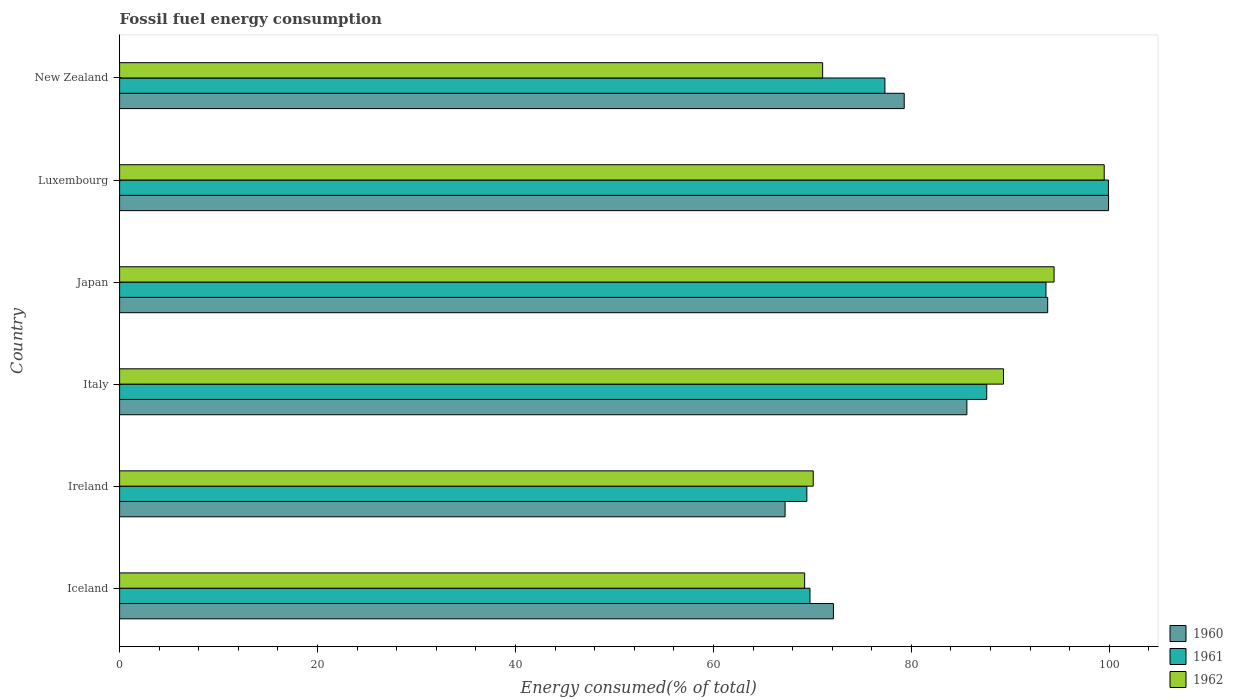How many different coloured bars are there?
Ensure brevity in your answer.  3. How many groups of bars are there?
Offer a terse response. 6. Are the number of bars per tick equal to the number of legend labels?
Your answer should be very brief. Yes. How many bars are there on the 1st tick from the top?
Provide a short and direct response. 3. How many bars are there on the 4th tick from the bottom?
Give a very brief answer. 3. What is the label of the 1st group of bars from the top?
Offer a very short reply. New Zealand. What is the percentage of energy consumed in 1960 in New Zealand?
Keep it short and to the point. 79.28. Across all countries, what is the maximum percentage of energy consumed in 1960?
Your answer should be very brief. 99.92. Across all countries, what is the minimum percentage of energy consumed in 1961?
Offer a terse response. 69.44. In which country was the percentage of energy consumed in 1960 maximum?
Offer a very short reply. Luxembourg. In which country was the percentage of energy consumed in 1961 minimum?
Provide a short and direct response. Ireland. What is the total percentage of energy consumed in 1960 in the graph?
Offer a very short reply. 497.96. What is the difference between the percentage of energy consumed in 1960 in Ireland and that in Japan?
Provide a short and direct response. -26.53. What is the difference between the percentage of energy consumed in 1960 in Japan and the percentage of energy consumed in 1962 in Ireland?
Provide a succinct answer. 23.69. What is the average percentage of energy consumed in 1960 per country?
Your answer should be very brief. 82.99. What is the difference between the percentage of energy consumed in 1961 and percentage of energy consumed in 1960 in Japan?
Keep it short and to the point. -0.17. What is the ratio of the percentage of energy consumed in 1960 in Ireland to that in Japan?
Your answer should be very brief. 0.72. Is the percentage of energy consumed in 1960 in Italy less than that in Luxembourg?
Ensure brevity in your answer.  Yes. Is the difference between the percentage of energy consumed in 1961 in Iceland and Italy greater than the difference between the percentage of energy consumed in 1960 in Iceland and Italy?
Keep it short and to the point. No. What is the difference between the highest and the second highest percentage of energy consumed in 1961?
Offer a terse response. 6.31. What is the difference between the highest and the lowest percentage of energy consumed in 1960?
Your response must be concise. 32.68. In how many countries, is the percentage of energy consumed in 1962 greater than the average percentage of energy consumed in 1962 taken over all countries?
Your answer should be very brief. 3. Is the sum of the percentage of energy consumed in 1961 in Ireland and Luxembourg greater than the maximum percentage of energy consumed in 1962 across all countries?
Your response must be concise. Yes. What does the 3rd bar from the top in Japan represents?
Ensure brevity in your answer.  1960. What does the 1st bar from the bottom in Japan represents?
Your answer should be compact. 1960. Are all the bars in the graph horizontal?
Keep it short and to the point. Yes. Are the values on the major ticks of X-axis written in scientific E-notation?
Provide a succinct answer. No. Does the graph contain any zero values?
Give a very brief answer. No. Does the graph contain grids?
Your response must be concise. No. How many legend labels are there?
Ensure brevity in your answer.  3. What is the title of the graph?
Make the answer very short. Fossil fuel energy consumption. What is the label or title of the X-axis?
Provide a short and direct response. Energy consumed(% of total). What is the Energy consumed(% of total) in 1960 in Iceland?
Your answer should be compact. 72.13. What is the Energy consumed(% of total) in 1961 in Iceland?
Give a very brief answer. 69.76. What is the Energy consumed(% of total) of 1962 in Iceland?
Offer a terse response. 69.22. What is the Energy consumed(% of total) of 1960 in Ireland?
Your answer should be compact. 67.24. What is the Energy consumed(% of total) in 1961 in Ireland?
Your response must be concise. 69.44. What is the Energy consumed(% of total) of 1962 in Ireland?
Your answer should be very brief. 70.09. What is the Energy consumed(% of total) of 1960 in Italy?
Your answer should be very brief. 85.61. What is the Energy consumed(% of total) of 1961 in Italy?
Provide a succinct answer. 87.62. What is the Energy consumed(% of total) in 1962 in Italy?
Ensure brevity in your answer.  89.31. What is the Energy consumed(% of total) of 1960 in Japan?
Keep it short and to the point. 93.78. What is the Energy consumed(% of total) of 1961 in Japan?
Provide a succinct answer. 93.6. What is the Energy consumed(% of total) of 1962 in Japan?
Your answer should be compact. 94.42. What is the Energy consumed(% of total) of 1960 in Luxembourg?
Your answer should be very brief. 99.92. What is the Energy consumed(% of total) in 1961 in Luxembourg?
Your response must be concise. 99.91. What is the Energy consumed(% of total) in 1962 in Luxembourg?
Provide a succinct answer. 99.49. What is the Energy consumed(% of total) of 1960 in New Zealand?
Keep it short and to the point. 79.28. What is the Energy consumed(% of total) of 1961 in New Zealand?
Your answer should be compact. 77.33. What is the Energy consumed(% of total) in 1962 in New Zealand?
Your answer should be very brief. 71.04. Across all countries, what is the maximum Energy consumed(% of total) in 1960?
Your response must be concise. 99.92. Across all countries, what is the maximum Energy consumed(% of total) of 1961?
Keep it short and to the point. 99.91. Across all countries, what is the maximum Energy consumed(% of total) of 1962?
Offer a very short reply. 99.49. Across all countries, what is the minimum Energy consumed(% of total) in 1960?
Your answer should be very brief. 67.24. Across all countries, what is the minimum Energy consumed(% of total) of 1961?
Offer a very short reply. 69.44. Across all countries, what is the minimum Energy consumed(% of total) in 1962?
Provide a succinct answer. 69.22. What is the total Energy consumed(% of total) of 1960 in the graph?
Your answer should be very brief. 497.96. What is the total Energy consumed(% of total) of 1961 in the graph?
Your answer should be compact. 497.66. What is the total Energy consumed(% of total) of 1962 in the graph?
Offer a terse response. 493.56. What is the difference between the Energy consumed(% of total) of 1960 in Iceland and that in Ireland?
Offer a terse response. 4.89. What is the difference between the Energy consumed(% of total) of 1961 in Iceland and that in Ireland?
Offer a very short reply. 0.32. What is the difference between the Energy consumed(% of total) in 1962 in Iceland and that in Ireland?
Keep it short and to the point. -0.87. What is the difference between the Energy consumed(% of total) in 1960 in Iceland and that in Italy?
Offer a terse response. -13.48. What is the difference between the Energy consumed(% of total) of 1961 in Iceland and that in Italy?
Offer a very short reply. -17.86. What is the difference between the Energy consumed(% of total) of 1962 in Iceland and that in Italy?
Give a very brief answer. -20.09. What is the difference between the Energy consumed(% of total) of 1960 in Iceland and that in Japan?
Your answer should be compact. -21.65. What is the difference between the Energy consumed(% of total) in 1961 in Iceland and that in Japan?
Your answer should be very brief. -23.85. What is the difference between the Energy consumed(% of total) in 1962 in Iceland and that in Japan?
Provide a short and direct response. -25.2. What is the difference between the Energy consumed(% of total) in 1960 in Iceland and that in Luxembourg?
Your answer should be very brief. -27.8. What is the difference between the Energy consumed(% of total) in 1961 in Iceland and that in Luxembourg?
Your response must be concise. -30.16. What is the difference between the Energy consumed(% of total) in 1962 in Iceland and that in Luxembourg?
Ensure brevity in your answer.  -30.27. What is the difference between the Energy consumed(% of total) in 1960 in Iceland and that in New Zealand?
Give a very brief answer. -7.15. What is the difference between the Energy consumed(% of total) in 1961 in Iceland and that in New Zealand?
Offer a very short reply. -7.57. What is the difference between the Energy consumed(% of total) of 1962 in Iceland and that in New Zealand?
Give a very brief answer. -1.82. What is the difference between the Energy consumed(% of total) of 1960 in Ireland and that in Italy?
Your answer should be compact. -18.37. What is the difference between the Energy consumed(% of total) of 1961 in Ireland and that in Italy?
Offer a terse response. -18.18. What is the difference between the Energy consumed(% of total) in 1962 in Ireland and that in Italy?
Your answer should be very brief. -19.23. What is the difference between the Energy consumed(% of total) in 1960 in Ireland and that in Japan?
Ensure brevity in your answer.  -26.53. What is the difference between the Energy consumed(% of total) of 1961 in Ireland and that in Japan?
Ensure brevity in your answer.  -24.16. What is the difference between the Energy consumed(% of total) in 1962 in Ireland and that in Japan?
Ensure brevity in your answer.  -24.34. What is the difference between the Energy consumed(% of total) in 1960 in Ireland and that in Luxembourg?
Your response must be concise. -32.68. What is the difference between the Energy consumed(% of total) in 1961 in Ireland and that in Luxembourg?
Provide a succinct answer. -30.47. What is the difference between the Energy consumed(% of total) in 1962 in Ireland and that in Luxembourg?
Provide a succinct answer. -29.4. What is the difference between the Energy consumed(% of total) in 1960 in Ireland and that in New Zealand?
Offer a terse response. -12.04. What is the difference between the Energy consumed(% of total) of 1961 in Ireland and that in New Zealand?
Provide a succinct answer. -7.89. What is the difference between the Energy consumed(% of total) of 1962 in Ireland and that in New Zealand?
Ensure brevity in your answer.  -0.95. What is the difference between the Energy consumed(% of total) in 1960 in Italy and that in Japan?
Your response must be concise. -8.17. What is the difference between the Energy consumed(% of total) of 1961 in Italy and that in Japan?
Your answer should be very brief. -5.99. What is the difference between the Energy consumed(% of total) of 1962 in Italy and that in Japan?
Make the answer very short. -5.11. What is the difference between the Energy consumed(% of total) of 1960 in Italy and that in Luxembourg?
Your answer should be compact. -14.31. What is the difference between the Energy consumed(% of total) in 1961 in Italy and that in Luxembourg?
Offer a very short reply. -12.3. What is the difference between the Energy consumed(% of total) in 1962 in Italy and that in Luxembourg?
Offer a very short reply. -10.18. What is the difference between the Energy consumed(% of total) in 1960 in Italy and that in New Zealand?
Make the answer very short. 6.33. What is the difference between the Energy consumed(% of total) of 1961 in Italy and that in New Zealand?
Your response must be concise. 10.29. What is the difference between the Energy consumed(% of total) in 1962 in Italy and that in New Zealand?
Your answer should be compact. 18.27. What is the difference between the Energy consumed(% of total) in 1960 in Japan and that in Luxembourg?
Offer a terse response. -6.15. What is the difference between the Energy consumed(% of total) in 1961 in Japan and that in Luxembourg?
Provide a short and direct response. -6.31. What is the difference between the Energy consumed(% of total) of 1962 in Japan and that in Luxembourg?
Your answer should be very brief. -5.07. What is the difference between the Energy consumed(% of total) in 1960 in Japan and that in New Zealand?
Give a very brief answer. 14.5. What is the difference between the Energy consumed(% of total) of 1961 in Japan and that in New Zealand?
Your answer should be very brief. 16.28. What is the difference between the Energy consumed(% of total) in 1962 in Japan and that in New Zealand?
Give a very brief answer. 23.38. What is the difference between the Energy consumed(% of total) of 1960 in Luxembourg and that in New Zealand?
Your answer should be compact. 20.65. What is the difference between the Energy consumed(% of total) in 1961 in Luxembourg and that in New Zealand?
Your answer should be compact. 22.58. What is the difference between the Energy consumed(% of total) of 1962 in Luxembourg and that in New Zealand?
Give a very brief answer. 28.45. What is the difference between the Energy consumed(% of total) of 1960 in Iceland and the Energy consumed(% of total) of 1961 in Ireland?
Keep it short and to the point. 2.69. What is the difference between the Energy consumed(% of total) in 1960 in Iceland and the Energy consumed(% of total) in 1962 in Ireland?
Provide a succinct answer. 2.04. What is the difference between the Energy consumed(% of total) of 1961 in Iceland and the Energy consumed(% of total) of 1962 in Ireland?
Provide a short and direct response. -0.33. What is the difference between the Energy consumed(% of total) of 1960 in Iceland and the Energy consumed(% of total) of 1961 in Italy?
Make the answer very short. -15.49. What is the difference between the Energy consumed(% of total) of 1960 in Iceland and the Energy consumed(% of total) of 1962 in Italy?
Provide a short and direct response. -17.18. What is the difference between the Energy consumed(% of total) in 1961 in Iceland and the Energy consumed(% of total) in 1962 in Italy?
Your answer should be compact. -19.55. What is the difference between the Energy consumed(% of total) in 1960 in Iceland and the Energy consumed(% of total) in 1961 in Japan?
Provide a succinct answer. -21.48. What is the difference between the Energy consumed(% of total) in 1960 in Iceland and the Energy consumed(% of total) in 1962 in Japan?
Make the answer very short. -22.29. What is the difference between the Energy consumed(% of total) in 1961 in Iceland and the Energy consumed(% of total) in 1962 in Japan?
Your answer should be very brief. -24.66. What is the difference between the Energy consumed(% of total) of 1960 in Iceland and the Energy consumed(% of total) of 1961 in Luxembourg?
Your answer should be very brief. -27.78. What is the difference between the Energy consumed(% of total) in 1960 in Iceland and the Energy consumed(% of total) in 1962 in Luxembourg?
Provide a short and direct response. -27.36. What is the difference between the Energy consumed(% of total) in 1961 in Iceland and the Energy consumed(% of total) in 1962 in Luxembourg?
Your response must be concise. -29.73. What is the difference between the Energy consumed(% of total) in 1960 in Iceland and the Energy consumed(% of total) in 1961 in New Zealand?
Make the answer very short. -5.2. What is the difference between the Energy consumed(% of total) in 1960 in Iceland and the Energy consumed(% of total) in 1962 in New Zealand?
Provide a succinct answer. 1.09. What is the difference between the Energy consumed(% of total) in 1961 in Iceland and the Energy consumed(% of total) in 1962 in New Zealand?
Provide a succinct answer. -1.28. What is the difference between the Energy consumed(% of total) in 1960 in Ireland and the Energy consumed(% of total) in 1961 in Italy?
Your answer should be very brief. -20.38. What is the difference between the Energy consumed(% of total) of 1960 in Ireland and the Energy consumed(% of total) of 1962 in Italy?
Offer a very short reply. -22.07. What is the difference between the Energy consumed(% of total) in 1961 in Ireland and the Energy consumed(% of total) in 1962 in Italy?
Ensure brevity in your answer.  -19.87. What is the difference between the Energy consumed(% of total) in 1960 in Ireland and the Energy consumed(% of total) in 1961 in Japan?
Ensure brevity in your answer.  -26.36. What is the difference between the Energy consumed(% of total) of 1960 in Ireland and the Energy consumed(% of total) of 1962 in Japan?
Offer a terse response. -27.18. What is the difference between the Energy consumed(% of total) in 1961 in Ireland and the Energy consumed(% of total) in 1962 in Japan?
Give a very brief answer. -24.98. What is the difference between the Energy consumed(% of total) of 1960 in Ireland and the Energy consumed(% of total) of 1961 in Luxembourg?
Keep it short and to the point. -32.67. What is the difference between the Energy consumed(% of total) of 1960 in Ireland and the Energy consumed(% of total) of 1962 in Luxembourg?
Make the answer very short. -32.25. What is the difference between the Energy consumed(% of total) in 1961 in Ireland and the Energy consumed(% of total) in 1962 in Luxembourg?
Ensure brevity in your answer.  -30.05. What is the difference between the Energy consumed(% of total) in 1960 in Ireland and the Energy consumed(% of total) in 1961 in New Zealand?
Provide a succinct answer. -10.09. What is the difference between the Energy consumed(% of total) in 1960 in Ireland and the Energy consumed(% of total) in 1962 in New Zealand?
Provide a succinct answer. -3.79. What is the difference between the Energy consumed(% of total) of 1961 in Ireland and the Energy consumed(% of total) of 1962 in New Zealand?
Offer a very short reply. -1.6. What is the difference between the Energy consumed(% of total) in 1960 in Italy and the Energy consumed(% of total) in 1961 in Japan?
Your response must be concise. -7.99. What is the difference between the Energy consumed(% of total) of 1960 in Italy and the Energy consumed(% of total) of 1962 in Japan?
Ensure brevity in your answer.  -8.81. What is the difference between the Energy consumed(% of total) of 1961 in Italy and the Energy consumed(% of total) of 1962 in Japan?
Offer a terse response. -6.8. What is the difference between the Energy consumed(% of total) in 1960 in Italy and the Energy consumed(% of total) in 1961 in Luxembourg?
Give a very brief answer. -14.3. What is the difference between the Energy consumed(% of total) of 1960 in Italy and the Energy consumed(% of total) of 1962 in Luxembourg?
Make the answer very short. -13.88. What is the difference between the Energy consumed(% of total) of 1961 in Italy and the Energy consumed(% of total) of 1962 in Luxembourg?
Your response must be concise. -11.87. What is the difference between the Energy consumed(% of total) of 1960 in Italy and the Energy consumed(% of total) of 1961 in New Zealand?
Your answer should be very brief. 8.28. What is the difference between the Energy consumed(% of total) in 1960 in Italy and the Energy consumed(% of total) in 1962 in New Zealand?
Your response must be concise. 14.57. What is the difference between the Energy consumed(% of total) in 1961 in Italy and the Energy consumed(% of total) in 1962 in New Zealand?
Keep it short and to the point. 16.58. What is the difference between the Energy consumed(% of total) of 1960 in Japan and the Energy consumed(% of total) of 1961 in Luxembourg?
Provide a short and direct response. -6.14. What is the difference between the Energy consumed(% of total) in 1960 in Japan and the Energy consumed(% of total) in 1962 in Luxembourg?
Your answer should be very brief. -5.71. What is the difference between the Energy consumed(% of total) of 1961 in Japan and the Energy consumed(% of total) of 1962 in Luxembourg?
Ensure brevity in your answer.  -5.88. What is the difference between the Energy consumed(% of total) of 1960 in Japan and the Energy consumed(% of total) of 1961 in New Zealand?
Keep it short and to the point. 16.45. What is the difference between the Energy consumed(% of total) of 1960 in Japan and the Energy consumed(% of total) of 1962 in New Zealand?
Provide a short and direct response. 22.74. What is the difference between the Energy consumed(% of total) of 1961 in Japan and the Energy consumed(% of total) of 1962 in New Zealand?
Make the answer very short. 22.57. What is the difference between the Energy consumed(% of total) in 1960 in Luxembourg and the Energy consumed(% of total) in 1961 in New Zealand?
Your response must be concise. 22.6. What is the difference between the Energy consumed(% of total) in 1960 in Luxembourg and the Energy consumed(% of total) in 1962 in New Zealand?
Offer a very short reply. 28.89. What is the difference between the Energy consumed(% of total) of 1961 in Luxembourg and the Energy consumed(% of total) of 1962 in New Zealand?
Make the answer very short. 28.88. What is the average Energy consumed(% of total) in 1960 per country?
Offer a terse response. 82.99. What is the average Energy consumed(% of total) of 1961 per country?
Ensure brevity in your answer.  82.94. What is the average Energy consumed(% of total) in 1962 per country?
Offer a very short reply. 82.26. What is the difference between the Energy consumed(% of total) in 1960 and Energy consumed(% of total) in 1961 in Iceland?
Your answer should be very brief. 2.37. What is the difference between the Energy consumed(% of total) in 1960 and Energy consumed(% of total) in 1962 in Iceland?
Make the answer very short. 2.91. What is the difference between the Energy consumed(% of total) in 1961 and Energy consumed(% of total) in 1962 in Iceland?
Ensure brevity in your answer.  0.54. What is the difference between the Energy consumed(% of total) in 1960 and Energy consumed(% of total) in 1961 in Ireland?
Provide a short and direct response. -2.2. What is the difference between the Energy consumed(% of total) of 1960 and Energy consumed(% of total) of 1962 in Ireland?
Your response must be concise. -2.84. What is the difference between the Energy consumed(% of total) of 1961 and Energy consumed(% of total) of 1962 in Ireland?
Make the answer very short. -0.65. What is the difference between the Energy consumed(% of total) of 1960 and Energy consumed(% of total) of 1961 in Italy?
Your response must be concise. -2.01. What is the difference between the Energy consumed(% of total) of 1960 and Energy consumed(% of total) of 1962 in Italy?
Ensure brevity in your answer.  -3.7. What is the difference between the Energy consumed(% of total) of 1961 and Energy consumed(% of total) of 1962 in Italy?
Your answer should be very brief. -1.69. What is the difference between the Energy consumed(% of total) of 1960 and Energy consumed(% of total) of 1961 in Japan?
Offer a very short reply. 0.17. What is the difference between the Energy consumed(% of total) in 1960 and Energy consumed(% of total) in 1962 in Japan?
Ensure brevity in your answer.  -0.64. What is the difference between the Energy consumed(% of total) of 1961 and Energy consumed(% of total) of 1962 in Japan?
Keep it short and to the point. -0.82. What is the difference between the Energy consumed(% of total) of 1960 and Energy consumed(% of total) of 1961 in Luxembourg?
Provide a short and direct response. 0.01. What is the difference between the Energy consumed(% of total) in 1960 and Energy consumed(% of total) in 1962 in Luxembourg?
Make the answer very short. 0.44. What is the difference between the Energy consumed(% of total) in 1961 and Energy consumed(% of total) in 1962 in Luxembourg?
Offer a very short reply. 0.42. What is the difference between the Energy consumed(% of total) in 1960 and Energy consumed(% of total) in 1961 in New Zealand?
Keep it short and to the point. 1.95. What is the difference between the Energy consumed(% of total) in 1960 and Energy consumed(% of total) in 1962 in New Zealand?
Ensure brevity in your answer.  8.24. What is the difference between the Energy consumed(% of total) of 1961 and Energy consumed(% of total) of 1962 in New Zealand?
Your answer should be compact. 6.29. What is the ratio of the Energy consumed(% of total) in 1960 in Iceland to that in Ireland?
Offer a very short reply. 1.07. What is the ratio of the Energy consumed(% of total) in 1961 in Iceland to that in Ireland?
Keep it short and to the point. 1. What is the ratio of the Energy consumed(% of total) in 1962 in Iceland to that in Ireland?
Your answer should be very brief. 0.99. What is the ratio of the Energy consumed(% of total) of 1960 in Iceland to that in Italy?
Make the answer very short. 0.84. What is the ratio of the Energy consumed(% of total) in 1961 in Iceland to that in Italy?
Provide a short and direct response. 0.8. What is the ratio of the Energy consumed(% of total) of 1962 in Iceland to that in Italy?
Your answer should be very brief. 0.78. What is the ratio of the Energy consumed(% of total) of 1960 in Iceland to that in Japan?
Offer a very short reply. 0.77. What is the ratio of the Energy consumed(% of total) in 1961 in Iceland to that in Japan?
Ensure brevity in your answer.  0.75. What is the ratio of the Energy consumed(% of total) in 1962 in Iceland to that in Japan?
Your response must be concise. 0.73. What is the ratio of the Energy consumed(% of total) in 1960 in Iceland to that in Luxembourg?
Make the answer very short. 0.72. What is the ratio of the Energy consumed(% of total) in 1961 in Iceland to that in Luxembourg?
Keep it short and to the point. 0.7. What is the ratio of the Energy consumed(% of total) of 1962 in Iceland to that in Luxembourg?
Your response must be concise. 0.7. What is the ratio of the Energy consumed(% of total) of 1960 in Iceland to that in New Zealand?
Keep it short and to the point. 0.91. What is the ratio of the Energy consumed(% of total) in 1961 in Iceland to that in New Zealand?
Make the answer very short. 0.9. What is the ratio of the Energy consumed(% of total) in 1962 in Iceland to that in New Zealand?
Make the answer very short. 0.97. What is the ratio of the Energy consumed(% of total) in 1960 in Ireland to that in Italy?
Your answer should be very brief. 0.79. What is the ratio of the Energy consumed(% of total) of 1961 in Ireland to that in Italy?
Make the answer very short. 0.79. What is the ratio of the Energy consumed(% of total) of 1962 in Ireland to that in Italy?
Provide a succinct answer. 0.78. What is the ratio of the Energy consumed(% of total) in 1960 in Ireland to that in Japan?
Make the answer very short. 0.72. What is the ratio of the Energy consumed(% of total) in 1961 in Ireland to that in Japan?
Keep it short and to the point. 0.74. What is the ratio of the Energy consumed(% of total) in 1962 in Ireland to that in Japan?
Ensure brevity in your answer.  0.74. What is the ratio of the Energy consumed(% of total) in 1960 in Ireland to that in Luxembourg?
Provide a short and direct response. 0.67. What is the ratio of the Energy consumed(% of total) of 1961 in Ireland to that in Luxembourg?
Provide a succinct answer. 0.69. What is the ratio of the Energy consumed(% of total) of 1962 in Ireland to that in Luxembourg?
Give a very brief answer. 0.7. What is the ratio of the Energy consumed(% of total) of 1960 in Ireland to that in New Zealand?
Ensure brevity in your answer.  0.85. What is the ratio of the Energy consumed(% of total) in 1961 in Ireland to that in New Zealand?
Offer a terse response. 0.9. What is the ratio of the Energy consumed(% of total) in 1962 in Ireland to that in New Zealand?
Your answer should be very brief. 0.99. What is the ratio of the Energy consumed(% of total) of 1960 in Italy to that in Japan?
Ensure brevity in your answer.  0.91. What is the ratio of the Energy consumed(% of total) in 1961 in Italy to that in Japan?
Give a very brief answer. 0.94. What is the ratio of the Energy consumed(% of total) of 1962 in Italy to that in Japan?
Your answer should be very brief. 0.95. What is the ratio of the Energy consumed(% of total) of 1960 in Italy to that in Luxembourg?
Your response must be concise. 0.86. What is the ratio of the Energy consumed(% of total) in 1961 in Italy to that in Luxembourg?
Your answer should be compact. 0.88. What is the ratio of the Energy consumed(% of total) of 1962 in Italy to that in Luxembourg?
Provide a short and direct response. 0.9. What is the ratio of the Energy consumed(% of total) in 1960 in Italy to that in New Zealand?
Provide a short and direct response. 1.08. What is the ratio of the Energy consumed(% of total) in 1961 in Italy to that in New Zealand?
Make the answer very short. 1.13. What is the ratio of the Energy consumed(% of total) of 1962 in Italy to that in New Zealand?
Your answer should be compact. 1.26. What is the ratio of the Energy consumed(% of total) in 1960 in Japan to that in Luxembourg?
Ensure brevity in your answer.  0.94. What is the ratio of the Energy consumed(% of total) in 1961 in Japan to that in Luxembourg?
Your answer should be very brief. 0.94. What is the ratio of the Energy consumed(% of total) of 1962 in Japan to that in Luxembourg?
Keep it short and to the point. 0.95. What is the ratio of the Energy consumed(% of total) in 1960 in Japan to that in New Zealand?
Give a very brief answer. 1.18. What is the ratio of the Energy consumed(% of total) of 1961 in Japan to that in New Zealand?
Give a very brief answer. 1.21. What is the ratio of the Energy consumed(% of total) of 1962 in Japan to that in New Zealand?
Give a very brief answer. 1.33. What is the ratio of the Energy consumed(% of total) in 1960 in Luxembourg to that in New Zealand?
Give a very brief answer. 1.26. What is the ratio of the Energy consumed(% of total) in 1961 in Luxembourg to that in New Zealand?
Ensure brevity in your answer.  1.29. What is the ratio of the Energy consumed(% of total) in 1962 in Luxembourg to that in New Zealand?
Make the answer very short. 1.4. What is the difference between the highest and the second highest Energy consumed(% of total) in 1960?
Your answer should be very brief. 6.15. What is the difference between the highest and the second highest Energy consumed(% of total) in 1961?
Provide a succinct answer. 6.31. What is the difference between the highest and the second highest Energy consumed(% of total) of 1962?
Provide a succinct answer. 5.07. What is the difference between the highest and the lowest Energy consumed(% of total) in 1960?
Give a very brief answer. 32.68. What is the difference between the highest and the lowest Energy consumed(% of total) in 1961?
Give a very brief answer. 30.47. What is the difference between the highest and the lowest Energy consumed(% of total) in 1962?
Your answer should be compact. 30.27. 